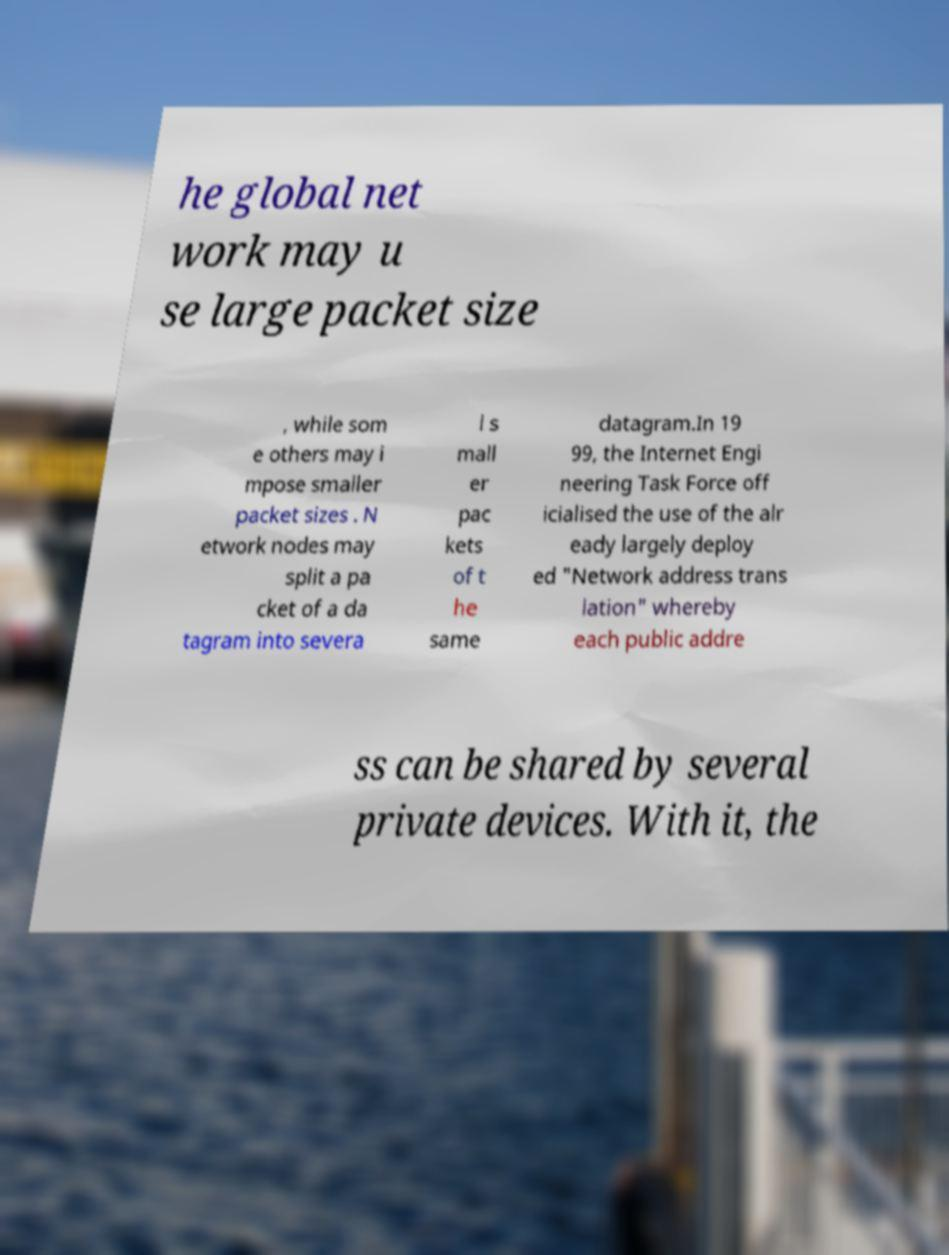Can you accurately transcribe the text from the provided image for me? he global net work may u se large packet size , while som e others may i mpose smaller packet sizes . N etwork nodes may split a pa cket of a da tagram into severa l s mall er pac kets of t he same datagram.In 19 99, the Internet Engi neering Task Force off icialised the use of the alr eady largely deploy ed "Network address trans lation" whereby each public addre ss can be shared by several private devices. With it, the 